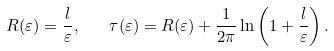Convert formula to latex. <formula><loc_0><loc_0><loc_500><loc_500>R ( \varepsilon ) = \frac { l } { \varepsilon } , \quad \tau ( \varepsilon ) = R ( \varepsilon ) + \frac { 1 } { 2 \pi } \ln \left ( 1 + \frac { l } { \varepsilon } \right ) .</formula> 